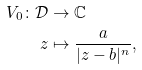Convert formula to latex. <formula><loc_0><loc_0><loc_500><loc_500>V _ { 0 } \colon \mathcal { D } & \to \mathbb { C } \\ z & \mapsto \frac { a } { | z - b | ^ { n } } ,</formula> 